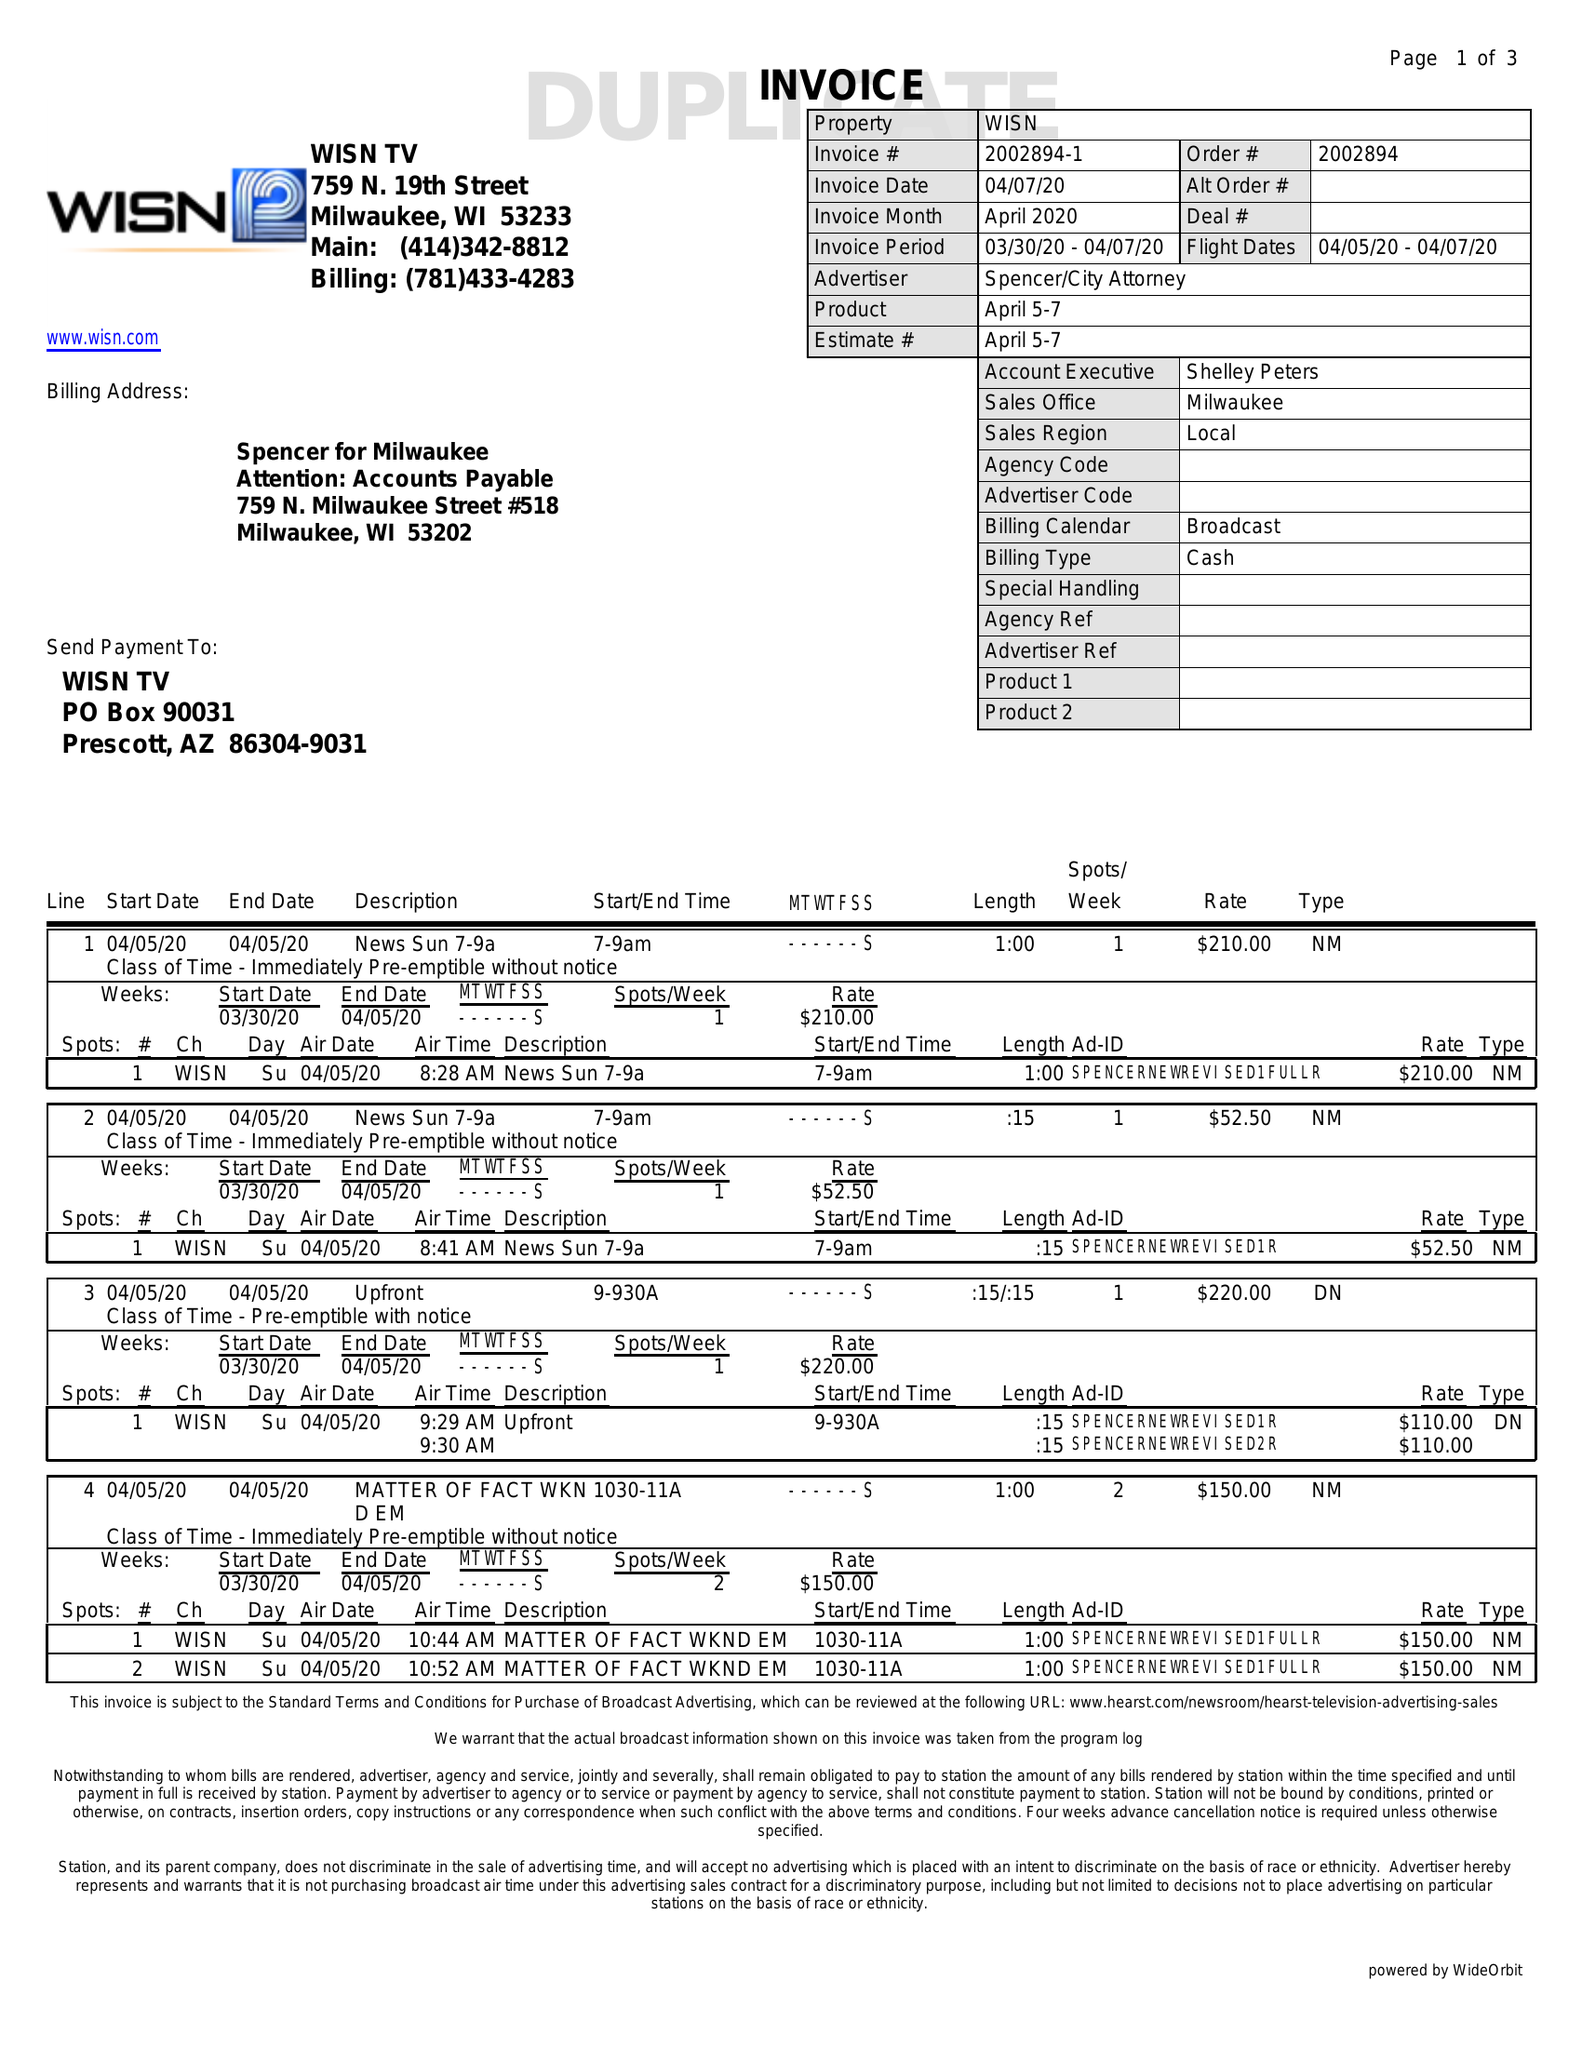What is the value for the gross_amount?
Answer the question using a single word or phrase. 2285.00 